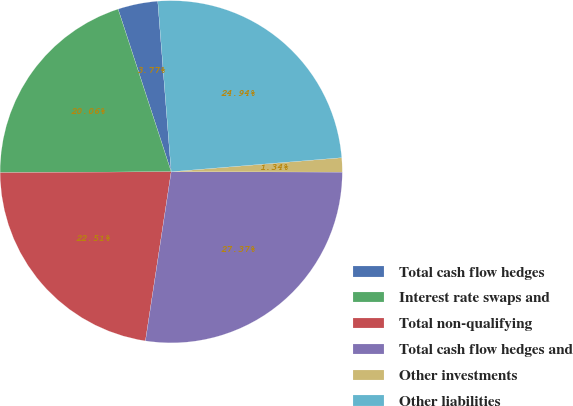<chart> <loc_0><loc_0><loc_500><loc_500><pie_chart><fcel>Total cash flow hedges<fcel>Interest rate swaps and<fcel>Total non-qualifying<fcel>Total cash flow hedges and<fcel>Other investments<fcel>Other liabilities<nl><fcel>3.77%<fcel>20.06%<fcel>22.51%<fcel>27.37%<fcel>1.34%<fcel>24.94%<nl></chart> 